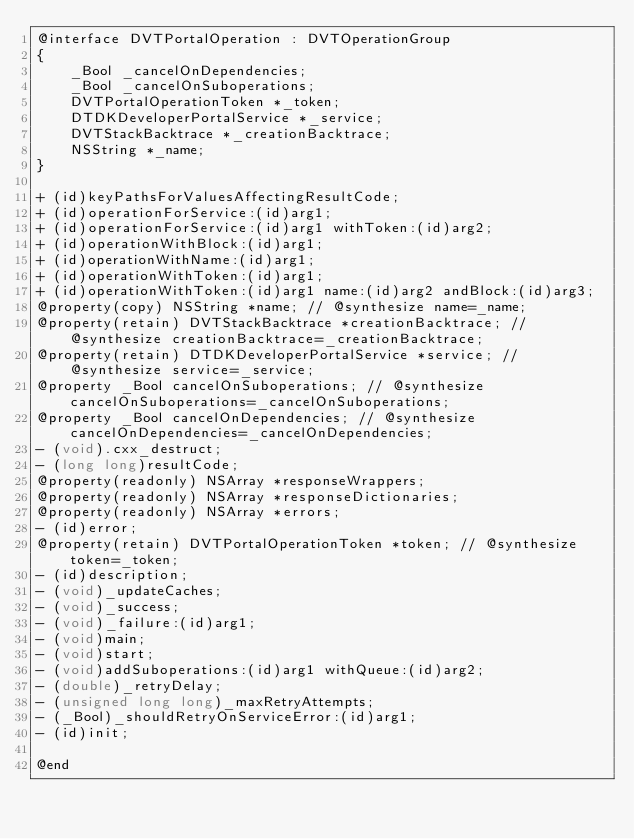Convert code to text. <code><loc_0><loc_0><loc_500><loc_500><_C_>@interface DVTPortalOperation : DVTOperationGroup
{
    _Bool _cancelOnDependencies;
    _Bool _cancelOnSuboperations;
    DVTPortalOperationToken *_token;
    DTDKDeveloperPortalService *_service;
    DVTStackBacktrace *_creationBacktrace;
    NSString *_name;
}

+ (id)keyPathsForValuesAffectingResultCode;
+ (id)operationForService:(id)arg1;
+ (id)operationForService:(id)arg1 withToken:(id)arg2;
+ (id)operationWithBlock:(id)arg1;
+ (id)operationWithName:(id)arg1;
+ (id)operationWithToken:(id)arg1;
+ (id)operationWithToken:(id)arg1 name:(id)arg2 andBlock:(id)arg3;
@property(copy) NSString *name; // @synthesize name=_name;
@property(retain) DVTStackBacktrace *creationBacktrace; // @synthesize creationBacktrace=_creationBacktrace;
@property(retain) DTDKDeveloperPortalService *service; // @synthesize service=_service;
@property _Bool cancelOnSuboperations; // @synthesize cancelOnSuboperations=_cancelOnSuboperations;
@property _Bool cancelOnDependencies; // @synthesize cancelOnDependencies=_cancelOnDependencies;
- (void).cxx_destruct;
- (long long)resultCode;
@property(readonly) NSArray *responseWrappers;
@property(readonly) NSArray *responseDictionaries;
@property(readonly) NSArray *errors;
- (id)error;
@property(retain) DVTPortalOperationToken *token; // @synthesize token=_token;
- (id)description;
- (void)_updateCaches;
- (void)_success;
- (void)_failure:(id)arg1;
- (void)main;
- (void)start;
- (void)addSuboperations:(id)arg1 withQueue:(id)arg2;
- (double)_retryDelay;
- (unsigned long long)_maxRetryAttempts;
- (_Bool)_shouldRetryOnServiceError:(id)arg1;
- (id)init;

@end

</code> 